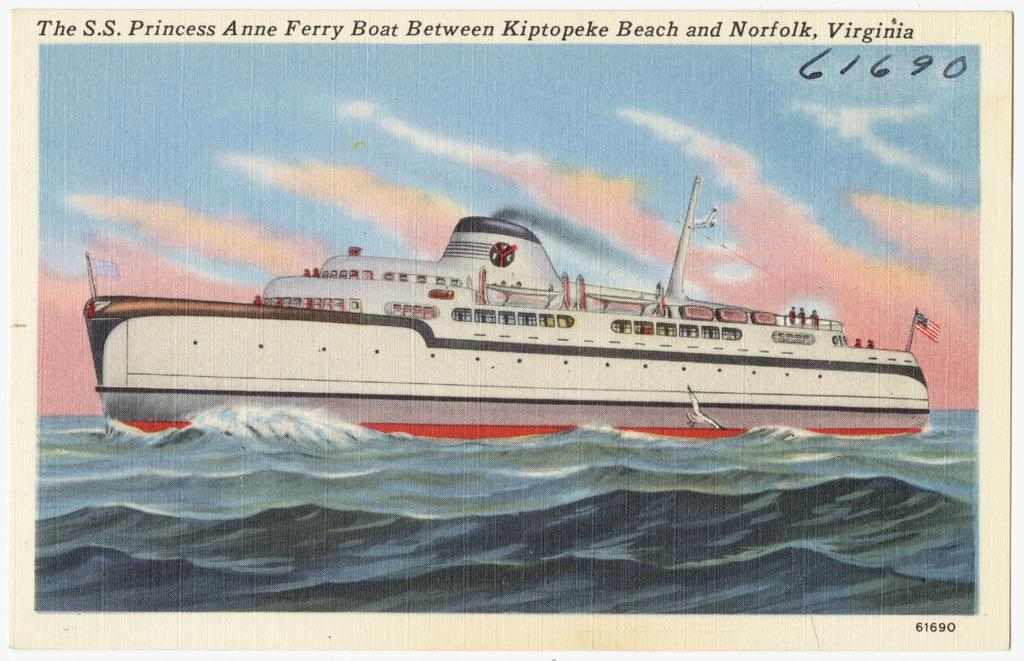What is the main subject of the image? The main subject of the image is a ship. Where is the ship located in the image? The ship is on the water in the image. What additional information is provided at the top of the image? There is text written at the top of the image. What type of brass instrument is being played on the ship in the image? There is no brass instrument or any indication of music being played in the image. 